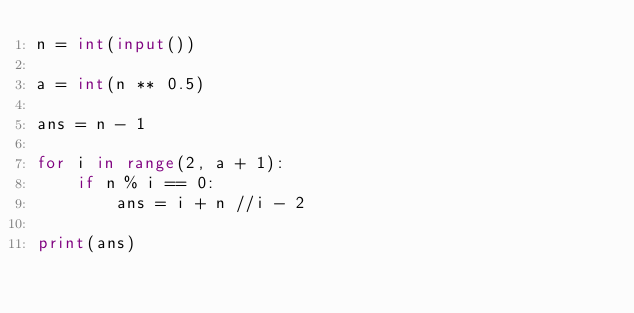Convert code to text. <code><loc_0><loc_0><loc_500><loc_500><_Python_>n = int(input())

a = int(n ** 0.5)

ans = n - 1

for i in range(2, a + 1):
    if n % i == 0:
        ans = i + n //i - 2

print(ans)</code> 